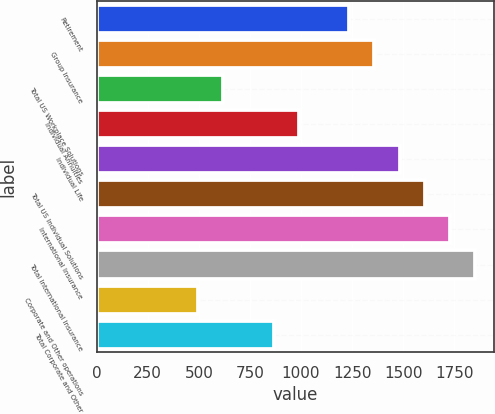Convert chart to OTSL. <chart><loc_0><loc_0><loc_500><loc_500><bar_chart><fcel>Retirement<fcel>Group Insurance<fcel>Total US Workplace Solutions<fcel>Individual Annuities<fcel>Individual Life<fcel>Total US Individual Solutions<fcel>International Insurance<fcel>Total International Insurance<fcel>Corporate and Other operations<fcel>Total Corporate and Other<nl><fcel>1236<fcel>1359.5<fcel>618.5<fcel>989<fcel>1483<fcel>1606.5<fcel>1730<fcel>1853.5<fcel>495<fcel>865.5<nl></chart> 